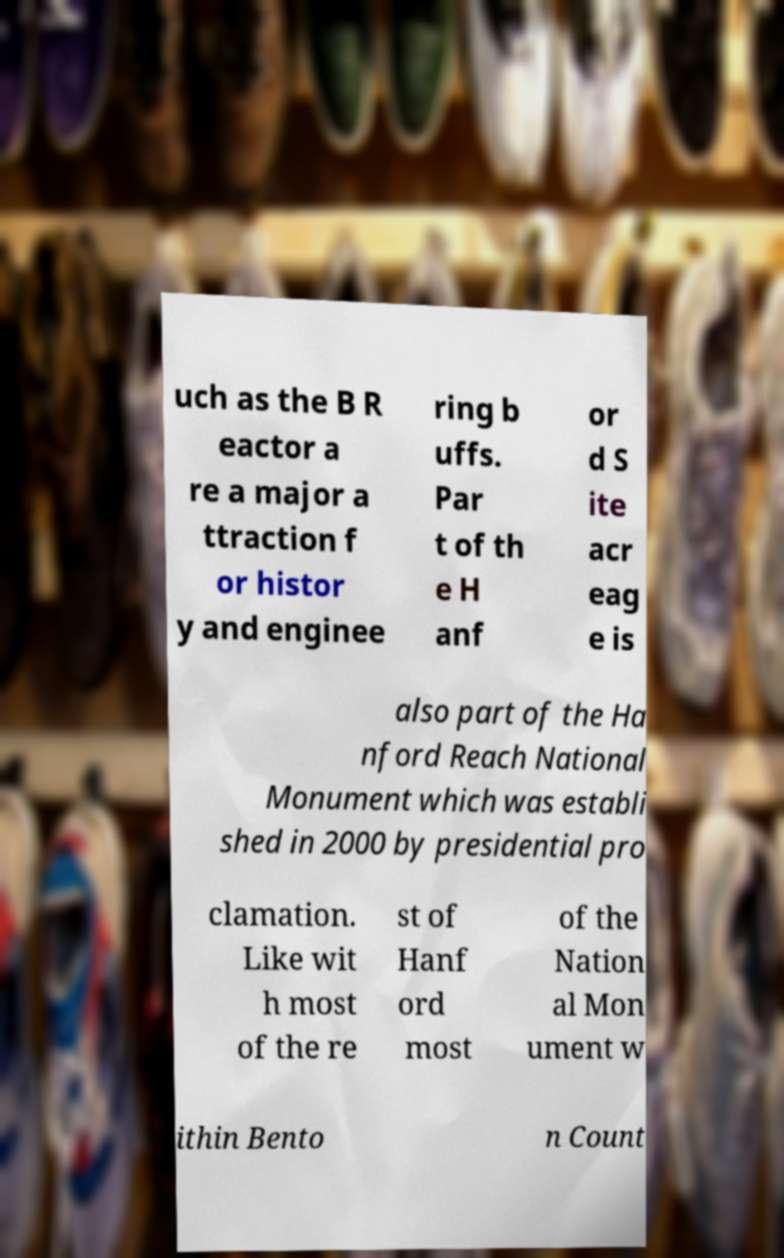There's text embedded in this image that I need extracted. Can you transcribe it verbatim? uch as the B R eactor a re a major a ttraction f or histor y and enginee ring b uffs. Par t of th e H anf or d S ite acr eag e is also part of the Ha nford Reach National Monument which was establi shed in 2000 by presidential pro clamation. Like wit h most of the re st of Hanf ord most of the Nation al Mon ument w ithin Bento n Count 